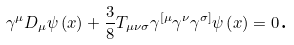Convert formula to latex. <formula><loc_0><loc_0><loc_500><loc_500>\gamma ^ { \mu } D _ { \mu } \psi \left ( x \right ) + \frac { 3 } { 8 } T _ { \mu \nu \sigma } \gamma ^ { [ \mu } \gamma ^ { \nu } \gamma ^ { \sigma ] } \psi \left ( x \right ) = 0 \text {.}</formula> 